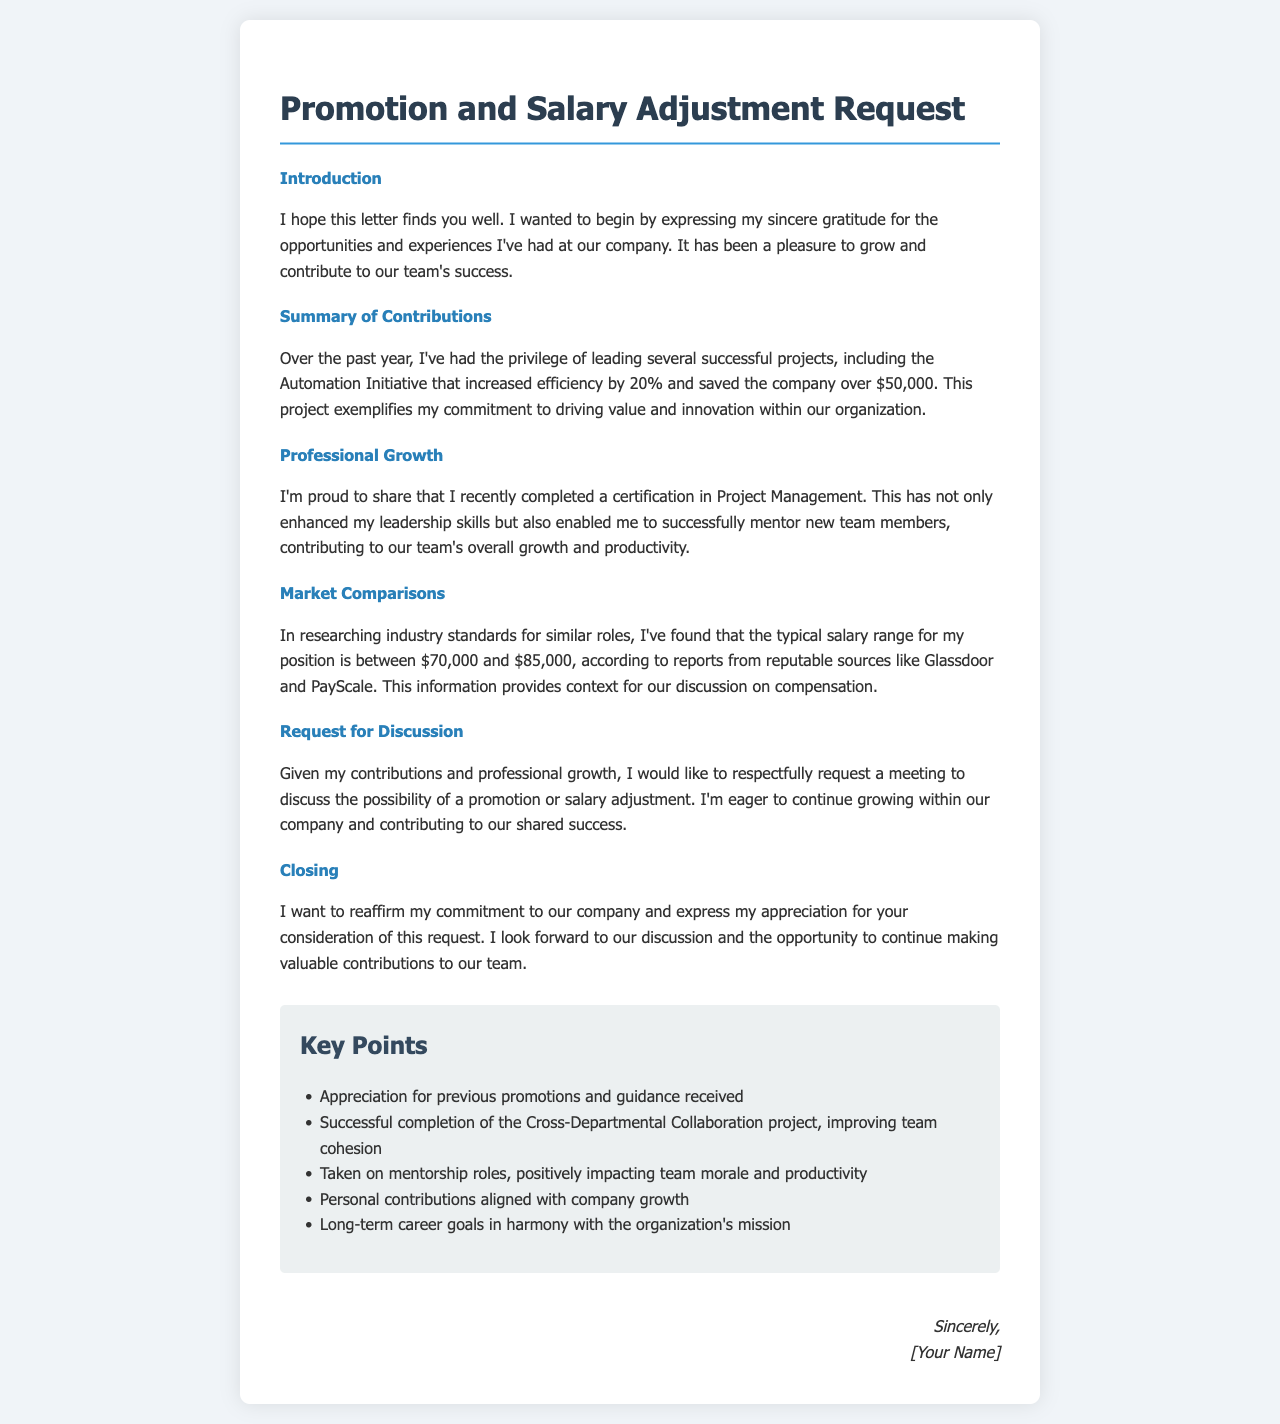What is the title of the letter? The title of the letter is the main heading that reflects its purpose.
Answer: Promotion and Salary Adjustment Request What project led to a 20% increase in efficiency? The project that exemplifies the author's contributions is described in the section about contributions.
Answer: Automation Initiative What certification did the author recently complete? The certification mentioned enhances leadership skills and is a notable professional development achievement.
Answer: Project Management What salary range is mentioned for similar roles? The salary range provides a context for the request and is found in the market comparisons section.
Answer: $70,000 to $85,000 What type of meeting is the author requesting? The author expresses a desire to meet to discuss career advancement opportunities within the company.
Answer: Meeting to discuss the possibility of a promotion or salary adjustment How much did the Automation Initiative save the company? This figure highlights the financial impact of the author's work and is specified in the contributions section.
Answer: Over $50,000 What is the author's commitment to the company? The author reiterates their dedication to the company in the closing section of the letter.
Answer: Commitment to our company What successful project improved team cohesion? The project mentioned relates to the author's role in fostering collaboration among team members.
Answer: Cross-Departmental Collaboration project How has the author contributed to team morale? The author mentions taking on roles that have a positive effect on team dynamics, which is relevant to team performance.
Answer: Mentorship roles 